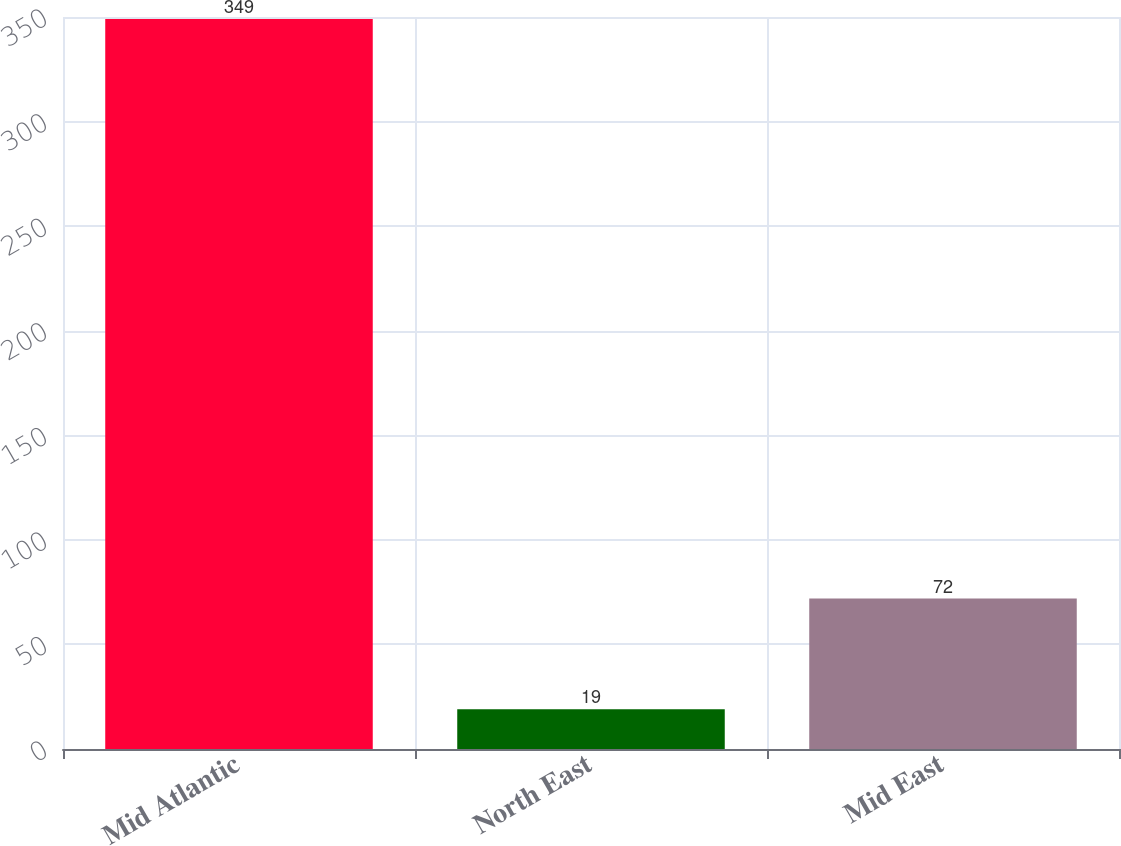Convert chart to OTSL. <chart><loc_0><loc_0><loc_500><loc_500><bar_chart><fcel>Mid Atlantic<fcel>North East<fcel>Mid East<nl><fcel>349<fcel>19<fcel>72<nl></chart> 